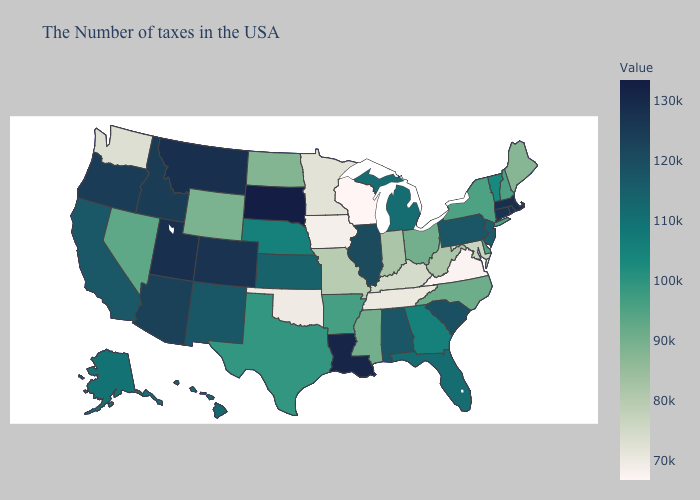Among the states that border Pennsylvania , does West Virginia have the highest value?
Be succinct. No. Which states hav the highest value in the Northeast?
Quick response, please. Massachusetts. Does Connecticut have the lowest value in the USA?
Concise answer only. No. Among the states that border Virginia , which have the lowest value?
Answer briefly. Tennessee. 